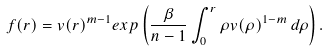Convert formula to latex. <formula><loc_0><loc_0><loc_500><loc_500>f ( r ) = v ( r ) ^ { m - 1 } e x p \left ( \frac { \beta } { n - 1 } \int _ { 0 } ^ { r } \rho v ( \rho ) ^ { 1 - m } \, d \rho \right ) .</formula> 